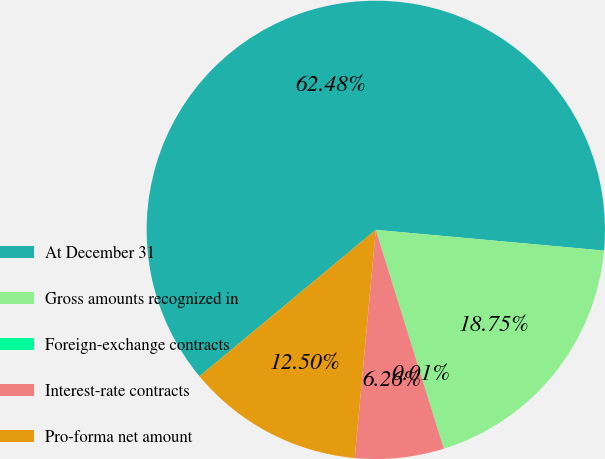Convert chart to OTSL. <chart><loc_0><loc_0><loc_500><loc_500><pie_chart><fcel>At December 31<fcel>Gross amounts recognized in<fcel>Foreign-exchange contracts<fcel>Interest-rate contracts<fcel>Pro-forma net amount<nl><fcel>62.47%<fcel>18.75%<fcel>0.01%<fcel>6.26%<fcel>12.5%<nl></chart> 